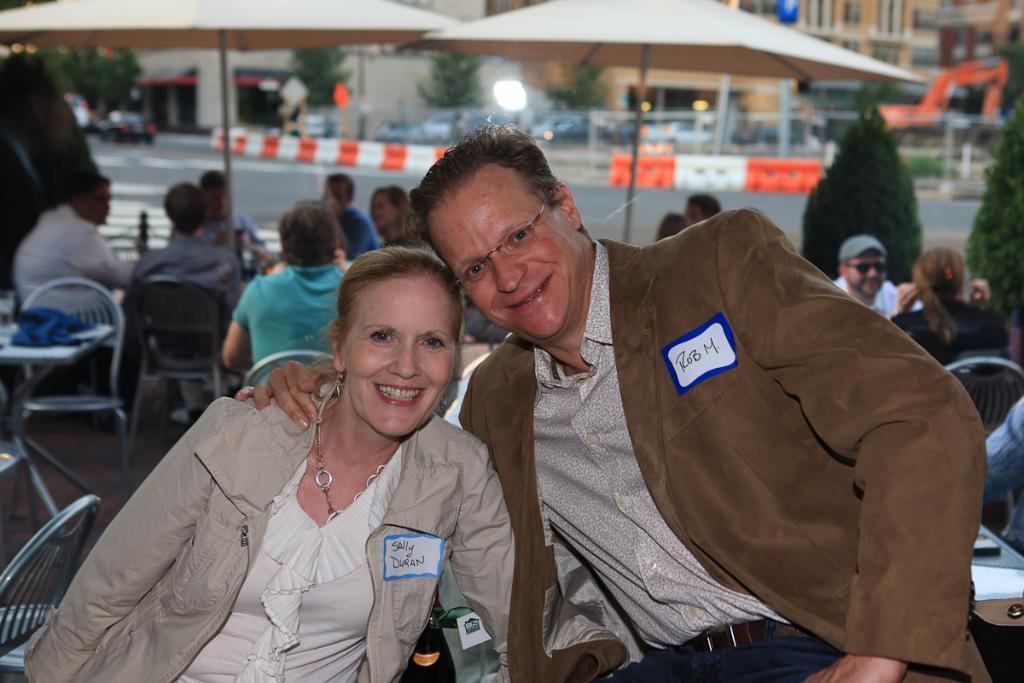How would you summarize this image in a sentence or two? In this picture there are two persons. Left side there is a lady. She is wearing grey color jacket and she is smiling. And to the right side there is a man sitting. He is wearing spectacles. He is smiling. In the background there are many people sitting. And there is a tent. And we can see some buildings to the top right corner. 